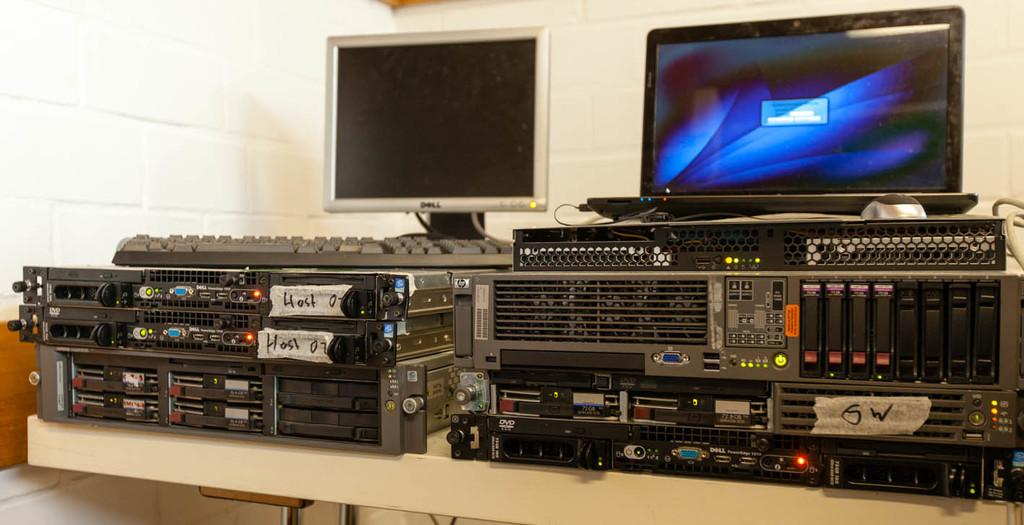What type of furniture is present in the image? There is a table in the image. What is placed on the table? There are monitors and electrical equipment on the table. Where is the book located in the image? There is no book present in the image. How much dust can be seen on the monitors in the image? The image does not provide information about the presence of dust on the monitors. 